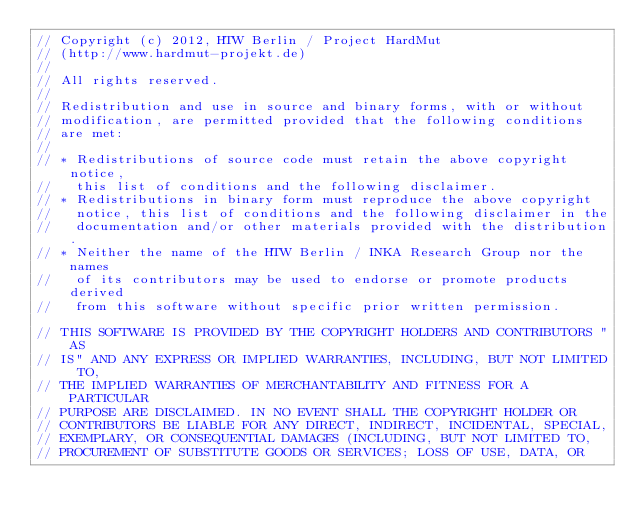Convert code to text. <code><loc_0><loc_0><loc_500><loc_500><_C_>// Copyright (c) 2012, HTW Berlin / Project HardMut
// (http://www.hardmut-projekt.de)
//
// All rights reserved.
//
// Redistribution and use in source and binary forms, with or without
// modification, are permitted provided that the following conditions
// are met:
//
// * Redistributions of source code must retain the above copyright notice,
//   this list of conditions and the following disclaimer.
// * Redistributions in binary form must reproduce the above copyright
//   notice, this list of conditions and the following disclaimer in the
//   documentation and/or other materials provided with the distribution.
// * Neither the name of the HTW Berlin / INKA Research Group nor the names
//   of its contributors may be used to endorse or promote products derived
//   from this software without specific prior written permission.

// THIS SOFTWARE IS PROVIDED BY THE COPYRIGHT HOLDERS AND CONTRIBUTORS "AS
// IS" AND ANY EXPRESS OR IMPLIED WARRANTIES, INCLUDING, BUT NOT LIMITED TO,
// THE IMPLIED WARRANTIES OF MERCHANTABILITY AND FITNESS FOR A PARTICULAR
// PURPOSE ARE DISCLAIMED. IN NO EVENT SHALL THE COPYRIGHT HOLDER OR
// CONTRIBUTORS BE LIABLE FOR ANY DIRECT, INDIRECT, INCIDENTAL, SPECIAL,
// EXEMPLARY, OR CONSEQUENTIAL DAMAGES (INCLUDING, BUT NOT LIMITED TO,
// PROCUREMENT OF SUBSTITUTE GOODS OR SERVICES; LOSS OF USE, DATA, OR</code> 